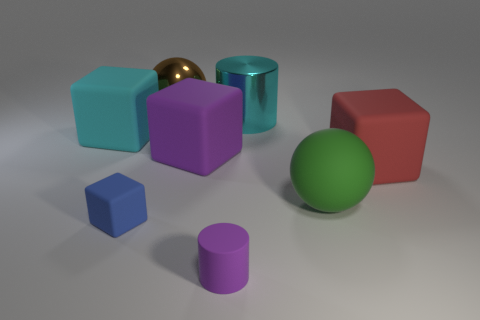There is a small blue thing; are there any cyan rubber objects in front of it?
Give a very brief answer. No. What number of large spheres are right of the large cyan object that is right of the brown metallic thing?
Your answer should be compact. 1. There is a purple cylinder; does it have the same size as the cyan thing on the left side of the shiny ball?
Provide a succinct answer. No. Are there any large rubber blocks of the same color as the matte cylinder?
Provide a short and direct response. Yes. What size is the purple block that is made of the same material as the large cyan cube?
Provide a succinct answer. Large. Do the red block and the large cylinder have the same material?
Offer a terse response. No. What color is the cylinder in front of the cyan object left of the big ball left of the metallic cylinder?
Keep it short and to the point. Purple. The green matte thing is what shape?
Your response must be concise. Sphere. Do the metal cylinder and the large thing to the left of the large brown sphere have the same color?
Provide a succinct answer. Yes. Are there an equal number of big red rubber things in front of the blue object and large brown metal cubes?
Keep it short and to the point. Yes. 